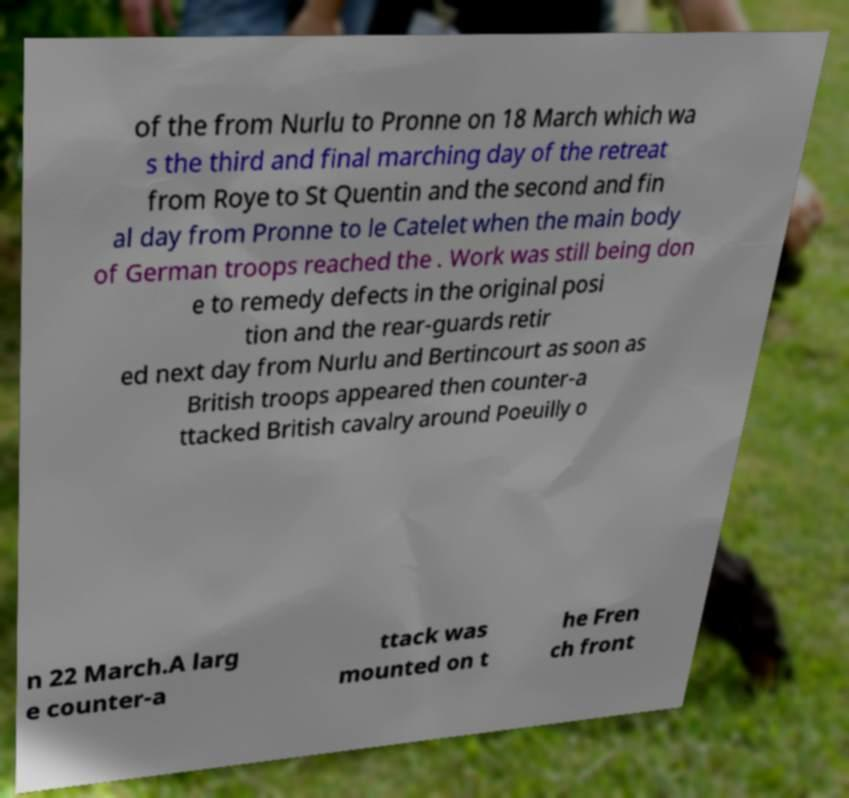Can you accurately transcribe the text from the provided image for me? of the from Nurlu to Pronne on 18 March which wa s the third and final marching day of the retreat from Roye to St Quentin and the second and fin al day from Pronne to le Catelet when the main body of German troops reached the . Work was still being don e to remedy defects in the original posi tion and the rear-guards retir ed next day from Nurlu and Bertincourt as soon as British troops appeared then counter-a ttacked British cavalry around Poeuilly o n 22 March.A larg e counter-a ttack was mounted on t he Fren ch front 